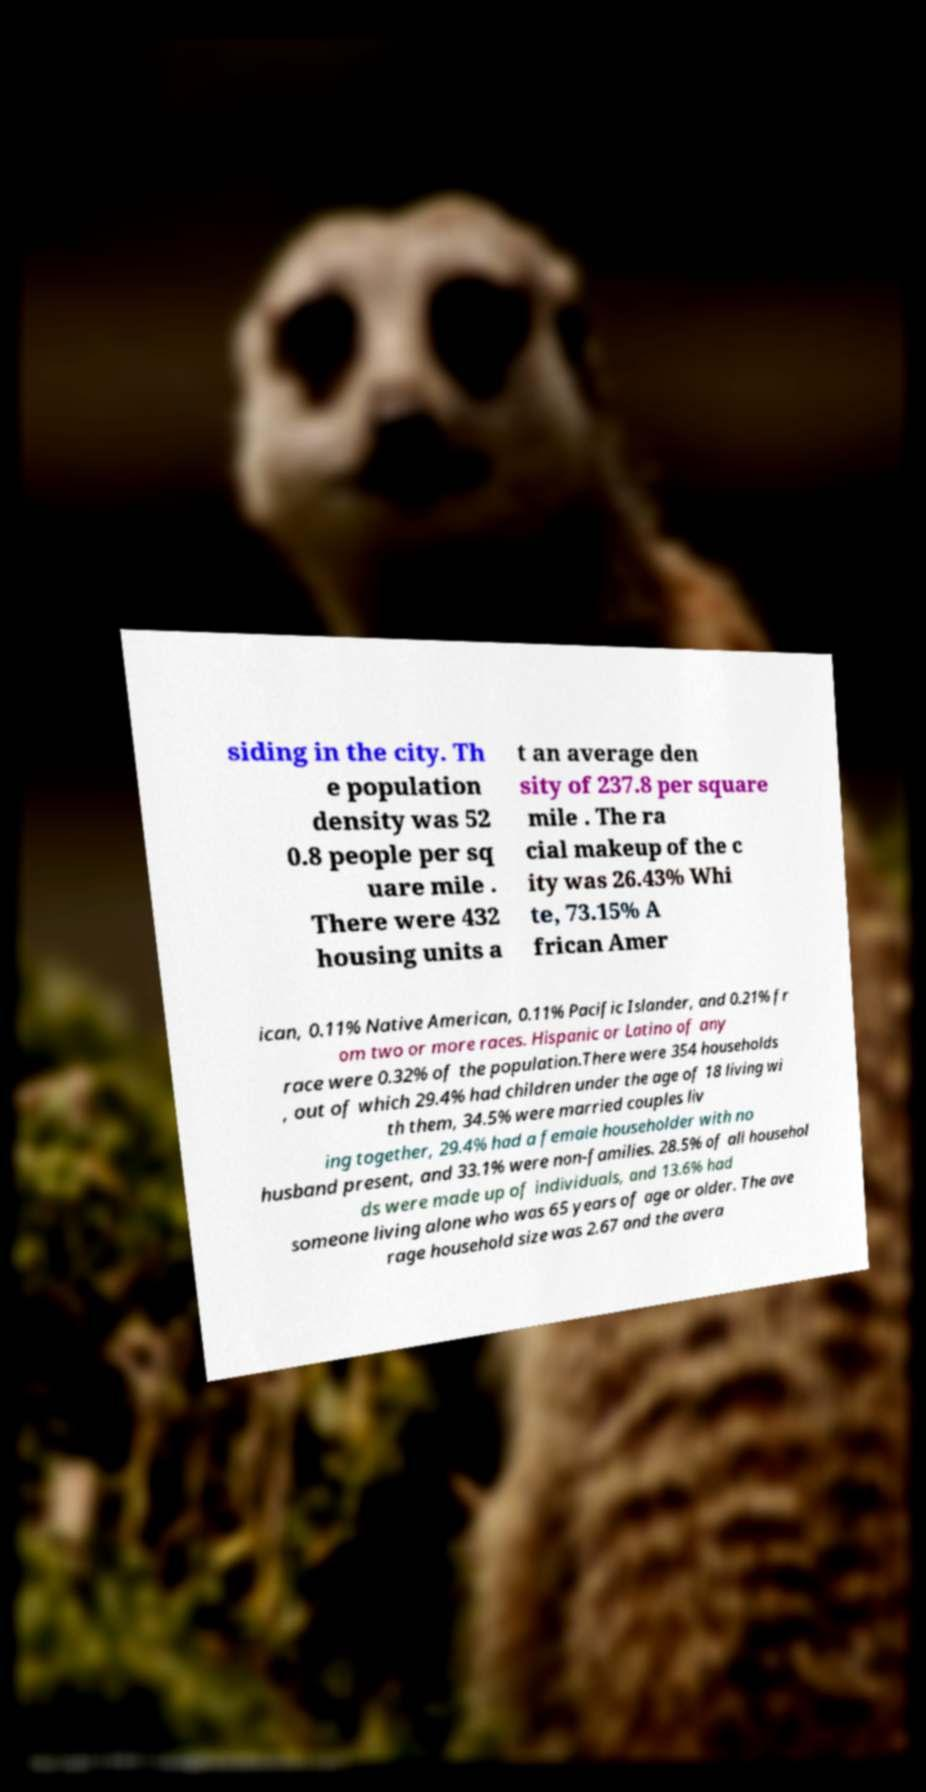There's text embedded in this image that I need extracted. Can you transcribe it verbatim? siding in the city. Th e population density was 52 0.8 people per sq uare mile . There were 432 housing units a t an average den sity of 237.8 per square mile . The ra cial makeup of the c ity was 26.43% Whi te, 73.15% A frican Amer ican, 0.11% Native American, 0.11% Pacific Islander, and 0.21% fr om two or more races. Hispanic or Latino of any race were 0.32% of the population.There were 354 households , out of which 29.4% had children under the age of 18 living wi th them, 34.5% were married couples liv ing together, 29.4% had a female householder with no husband present, and 33.1% were non-families. 28.5% of all househol ds were made up of individuals, and 13.6% had someone living alone who was 65 years of age or older. The ave rage household size was 2.67 and the avera 